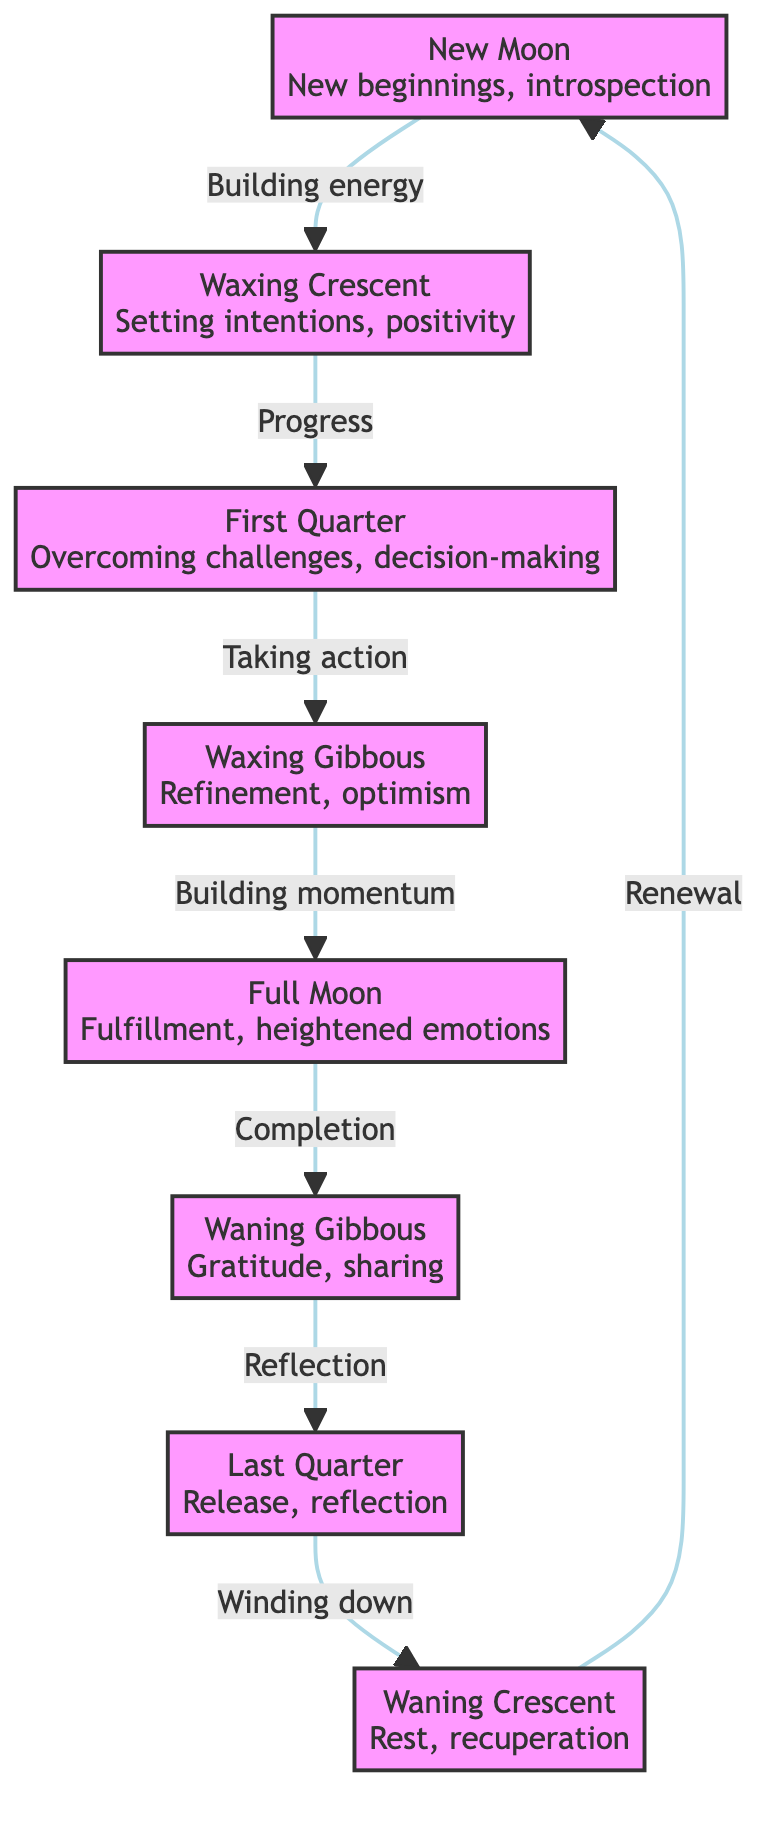What is the first phase of the Moon depicted in the diagram? The diagram starts with the "New Moon" phase, which is the first node displayed.
Answer: New Moon How many phases of the Moon are represented in the diagram? The diagram includes eight distinct phases, each represented as a node in the flowchart.
Answer: Eight What phase comes after the Full Moon? Following the Full Moon, the next phase as per the diagram is the "Waning Gibbous" phase, which connects directly below it.
Answer: Waning Gibbous What action is associated with the First Quarter phase? According to the diagram, the First Quarter phase is associated with "Taking action", which is indicated by the text linked to this node.
Answer: Taking action What is the relationship between the Waxing Crescent and the First Quarter phases? The Waxing Crescent phase leads to the First Quarter phase, indicating a progression or flow in the context of lunar phases.
Answer: Progress What is emphasized during the Full Moon phase? The diagram emphasizes "Fulfillment" and "heightened emotions" during the Full Moon phase, highlighting the unique characteristics of this phase.
Answer: Fulfillment What does the transition from the Last Quarter to the Waning Crescent represent? The transition signifies "Winding down," indicating a process of reflection and gradual closure before renewal.
Answer: Winding down What is the key theme associated with the Waning Crescent phase? The key theme linked to the Waning Crescent phase in the diagram is "Rest, recuperation," reflecting a time for recharging and reflection.
Answer: Rest, recuperation 